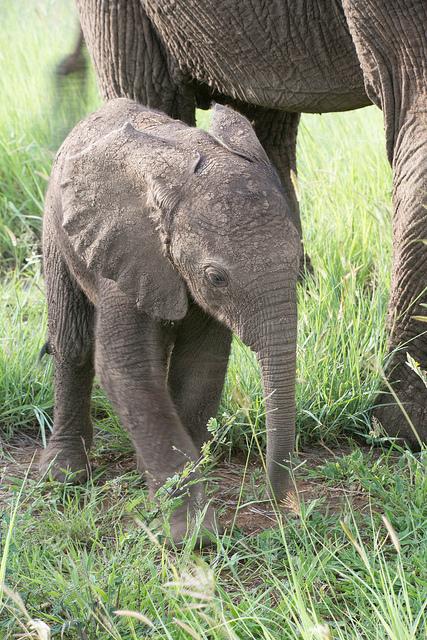Is it a baby elephant?
Give a very brief answer. Yes. How tall is the baby elephant?
Quick response, please. 3 feet. What is the green stuff under the elephants?
Quick response, please. Grass. 